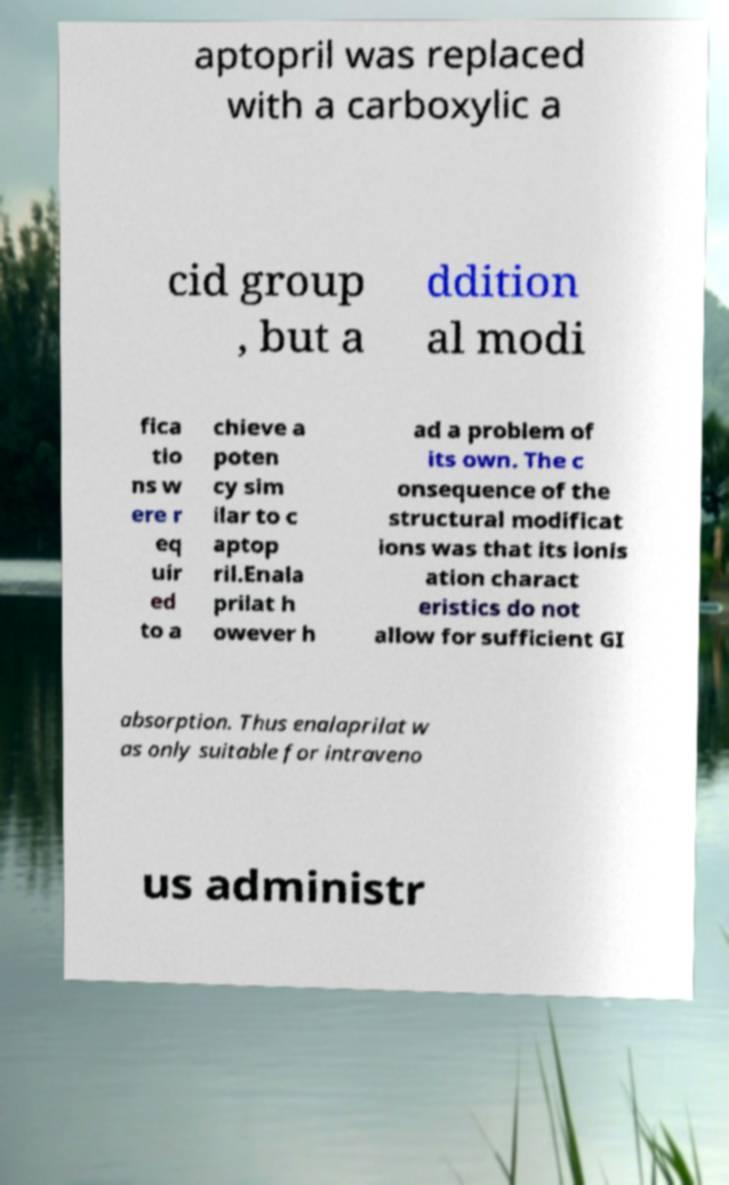Can you accurately transcribe the text from the provided image for me? aptopril was replaced with a carboxylic a cid group , but a ddition al modi fica tio ns w ere r eq uir ed to a chieve a poten cy sim ilar to c aptop ril.Enala prilat h owever h ad a problem of its own. The c onsequence of the structural modificat ions was that its ionis ation charact eristics do not allow for sufficient GI absorption. Thus enalaprilat w as only suitable for intraveno us administr 